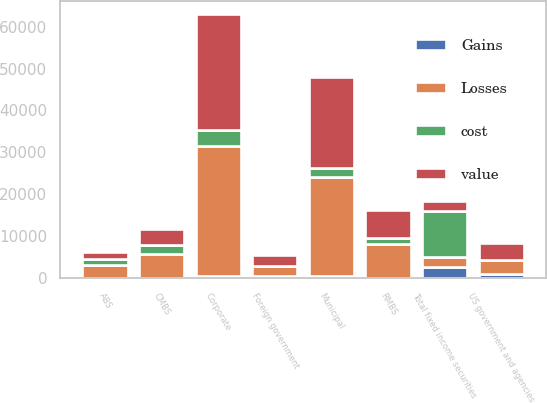Convert chart. <chart><loc_0><loc_0><loc_500><loc_500><stacked_bar_chart><ecel><fcel>US government and agencies<fcel>Municipal<fcel>Corporate<fcel>Foreign government<fcel>RMBS<fcel>CMBS<fcel>ABS<fcel>Total fixed income securities<nl><fcel>Losses<fcel>3272<fcel>23565<fcel>31040<fcel>2206<fcel>8010<fcel>5840<fcel>3135<fcel>2375.5<nl><fcel>Gains<fcel>963<fcel>467<fcel>463<fcel>544<fcel>93<fcel>10<fcel>5<fcel>2545<nl><fcel>cost<fcel>1<fcel>2184<fcel>3876<fcel>75<fcel>1538<fcel>2004<fcel>1353<fcel>11041<nl><fcel>value<fcel>4234<fcel>21848<fcel>27627<fcel>2675<fcel>6565<fcel>3846<fcel>1787<fcel>2375.5<nl></chart> 